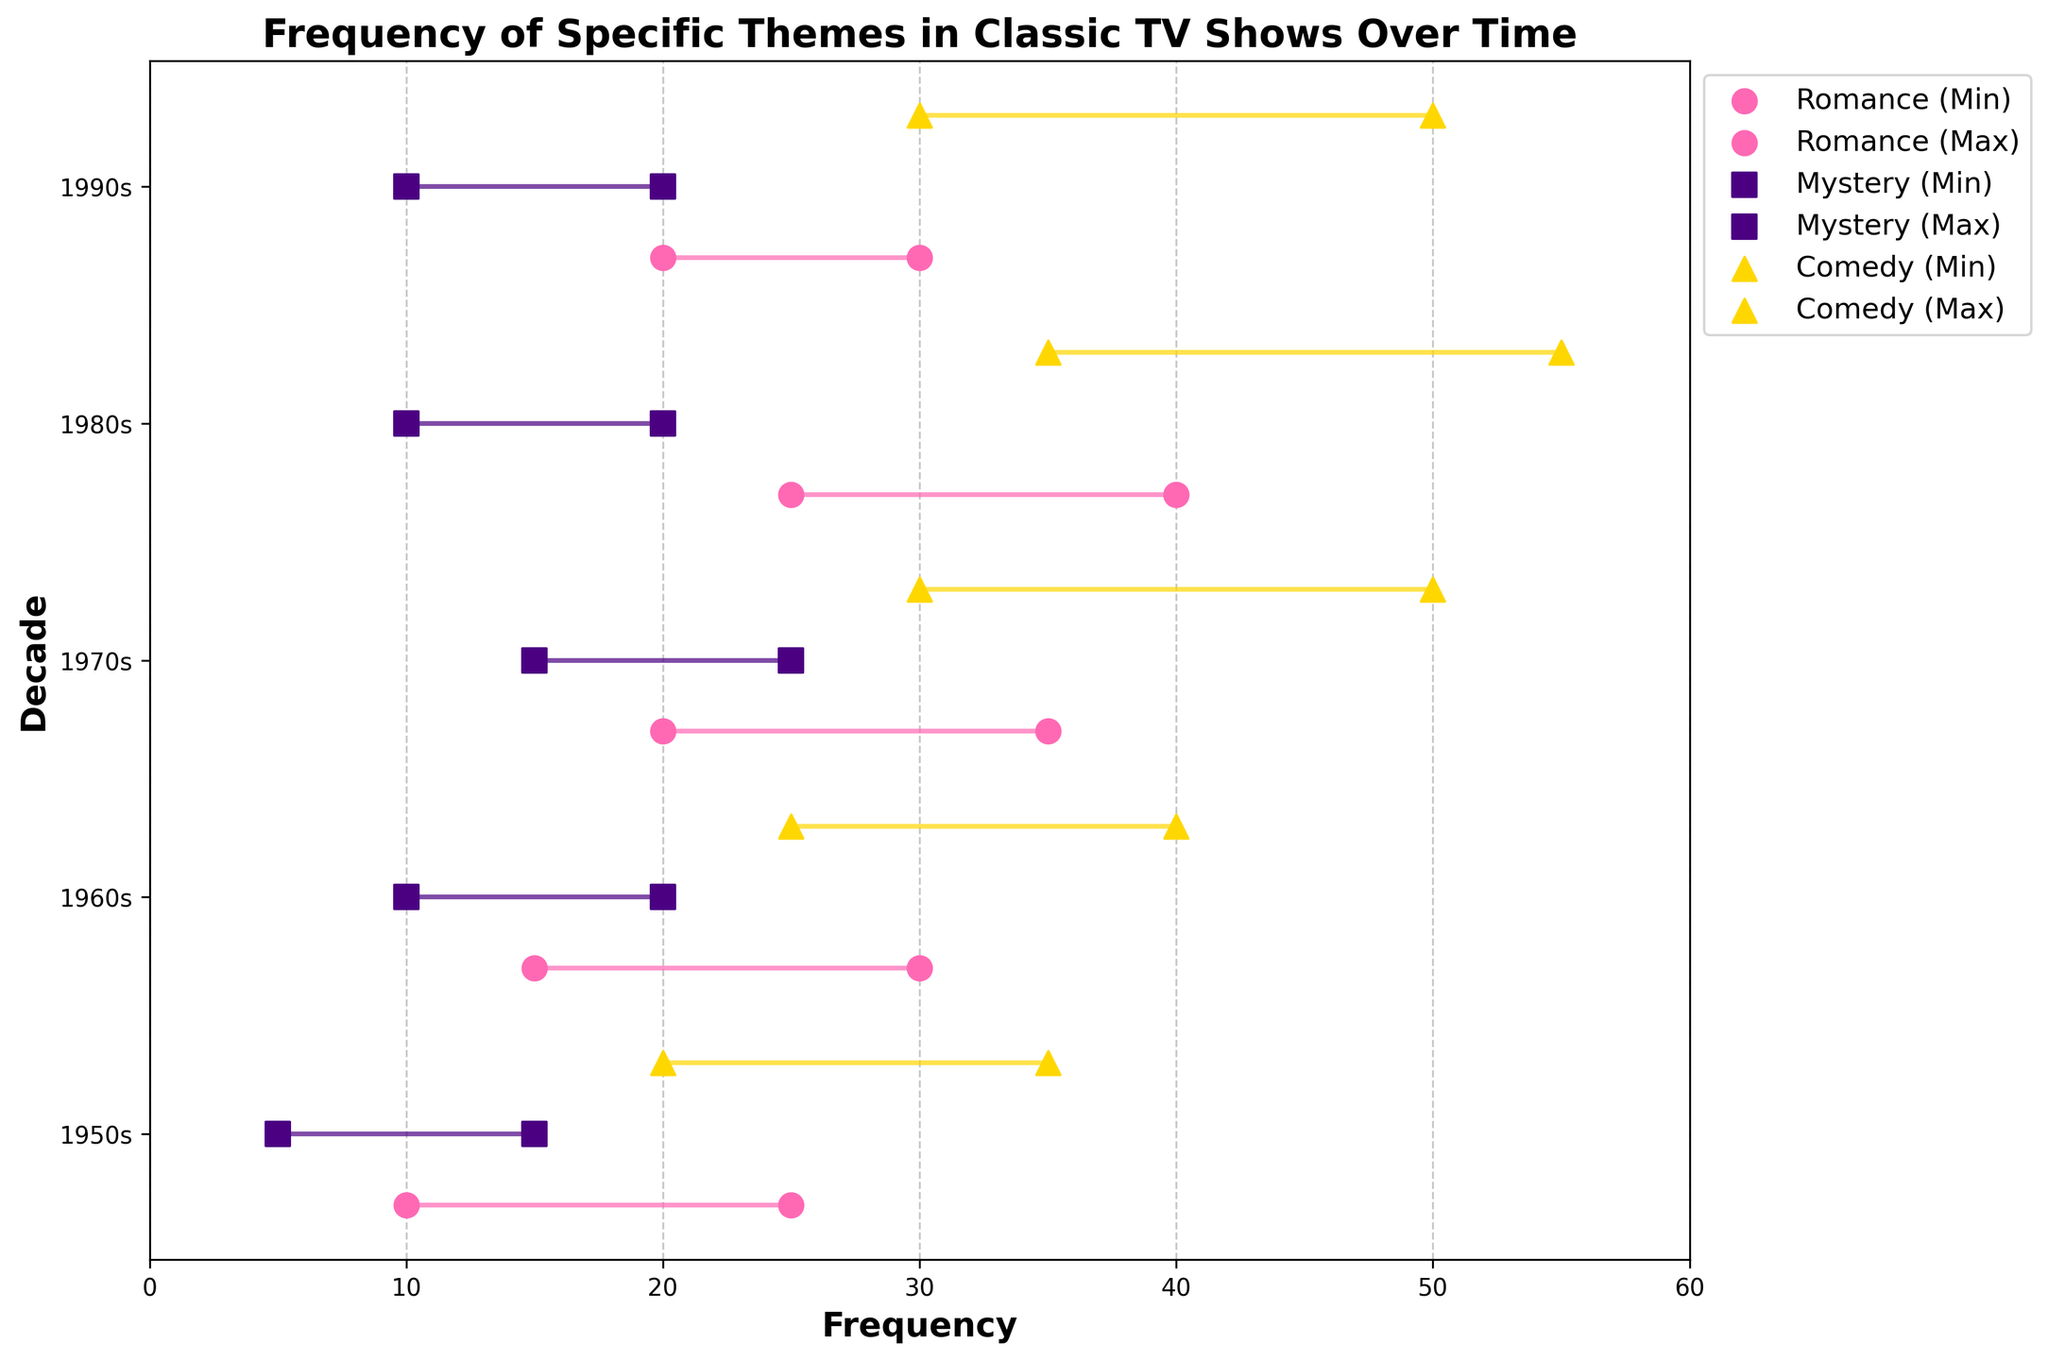What is the title of the plot? The title is located at the top of the plot.
Answer: Frequency of Specific Themes in Classic TV Shows Over Time Which genre has the highest maximum frequency in the 1980s? Look at the data points for each genre in the 1980s and compare their maximum frequencies.
Answer: Comedy What is the range of frequencies for Romance in the 1970s? Find the minimum and maximum frequencies for Romance in the 1970s and calculate their difference.
Answer: 15 (Maximum: 35, Minimum: 20) Which decade shows the biggest increase in maximum frequency for Comedy compared to the previous decade? By comparing the maximum frequencies of Comedy in each decade, find the largest increase from one decade to the next.
Answer: 1980s In which decades do all genres have overlapping frequency ranges? Check which decades have overlapping intervals of minimum and maximum frequencies for all three genres.
Answer: 1960s How do the frequency ranges of Mystery in the 1980s compare to those in the 1970s? Observe the minimum and maximum frequencies for Mystery in both decades and compare them.
Answer: Both minimum and maximum frequencies are lower in the 1980s than in the 1970s What is the total range of maximum frequencies across all decades for the genre Mystery? Add up the maximum frequencies of Mystery for each decade to find the total range.
Answer: 100 (15+20+25+20+20) How does the frequency trend of Romance differ from that of Comedy over the decades? Compare the frequency ranges of Romance and Comedy from the 1950s to the 1990s to identify differences in trends.
Answer: Romance peaks in the 1980s and declines; Comedy rises steadily until the 1980s, then stabilizes Does the 1950s decade show any genre with non-overlapping frequency ranges? Check if for any genre, the range marked by minimum and maximum frequencies does not overlap with the ranges of other genres.
Answer: No Which genre had the most significant drop in maximum frequency between any two decades? By examining the maximum frequency of each genre in consecutive decades, determine which had the largest decline.
Answer: Romance (from 1980s to 1990s, dropped from 40 to 30) 